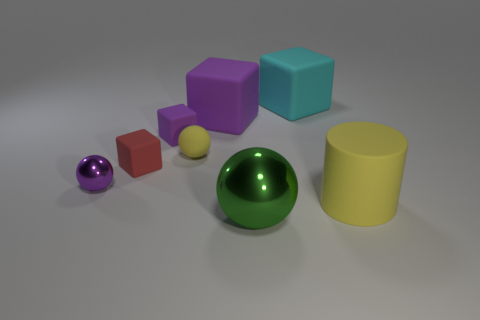There is a object that is in front of the purple sphere and behind the green sphere; how big is it?
Provide a succinct answer. Large. Is the number of red matte cubes that are in front of the tiny metallic object less than the number of objects in front of the small yellow thing?
Your answer should be very brief. Yes. How many other things are there of the same material as the big sphere?
Provide a succinct answer. 1. There is a large block to the left of the cyan rubber thing; is it the same color as the tiny metallic object?
Keep it short and to the point. Yes. There is a thing that is in front of the big yellow cylinder; is there a green metal sphere that is left of it?
Ensure brevity in your answer.  No. What is the material of the ball that is right of the tiny purple metallic object and behind the big cylinder?
Provide a succinct answer. Rubber. The tiny thing that is the same material as the large green ball is what shape?
Ensure brevity in your answer.  Sphere. Are there any other things that are the same shape as the big yellow rubber object?
Your answer should be compact. No. Does the sphere that is behind the tiny purple metallic ball have the same material as the tiny purple ball?
Make the answer very short. No. What is the material of the big thing that is in front of the big rubber cylinder?
Provide a short and direct response. Metal. 